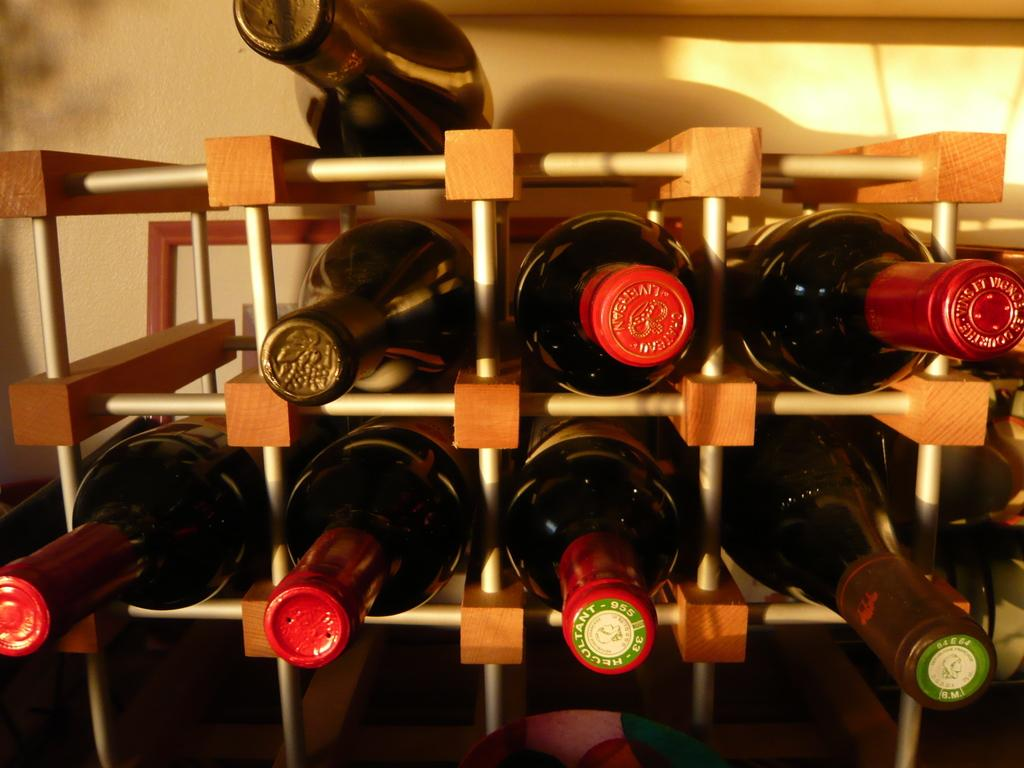What types of objects are present in the image? There are different bottles in the image. How are the bottles organized in the image? The bottles are kept in a container with racks. Are all the bottles inside the container? No, one bottle is kept outside the container. What religious symbol can be seen on the bottles in the image? There is no religious symbol present on the bottles in the image. 